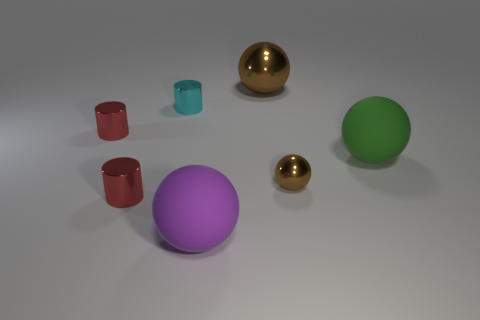Subtract all brown balls. How many red cylinders are left? 2 Subtract all large purple matte spheres. How many spheres are left? 3 Subtract all purple spheres. How many spheres are left? 3 Add 1 metal cylinders. How many objects exist? 8 Subtract all cyan balls. Subtract all red cubes. How many balls are left? 4 Subtract all cylinders. How many objects are left? 4 Add 5 purple balls. How many purple balls exist? 6 Subtract 1 purple spheres. How many objects are left? 6 Subtract all small cyan metallic cylinders. Subtract all large red rubber objects. How many objects are left? 6 Add 7 large purple matte spheres. How many large purple matte spheres are left? 8 